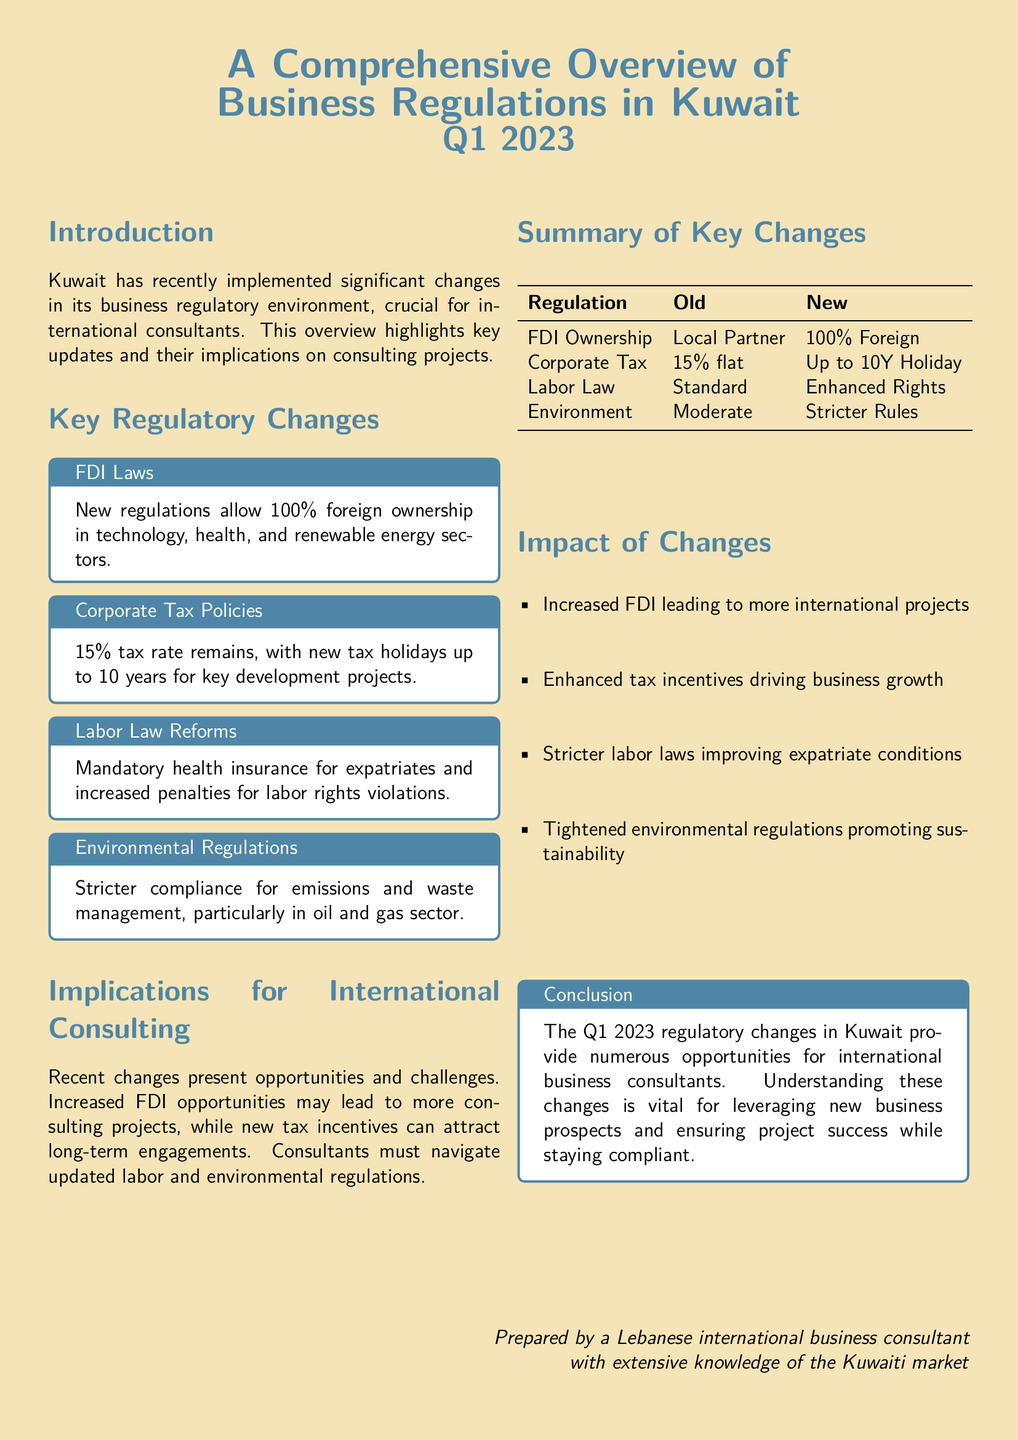What is the corporate tax rate in Kuwait? The document states that the corporate tax rate is maintained at 15%.
Answer: 15% What new ownership percentage is allowed for foreign investors? The document indicates that new regulations allow 100% foreign ownership in specified industries.
Answer: 100% foreign How long can tax holidays last for key development projects? The document specifies that tax holidays can last up to 10 years.
Answer: 10 years What is a significant penalty introduced in the labor law reforms? The document points out that there are increased penalties for labor rights violations.
Answer: Increased penalties Which sectors benefit from the new Foreign Direct Investment laws? The document mentions that the technology, health, and renewable energy sectors benefit from these laws.
Answer: Technology, health, renewable energy What is one impact of the enhanced labor laws mentioned? The document states that enhanced labor laws improve conditions for expatriates.
Answer: Improved conditions What is required for expatriates under the new labor law reforms? The document specifies that mandatory health insurance is a requirement for expatriates.
Answer: Mandatory health insurance What does the document suggest international consultants must navigate? According to the document, consultants must navigate updated labor and environmental regulations.
Answer: Updated labor and environmental regulations What does the conclusion suggest about the Q1 2023 changes? The conclusion indicates that these changes provide numerous opportunities for international business consultants.
Answer: Numerous opportunities 